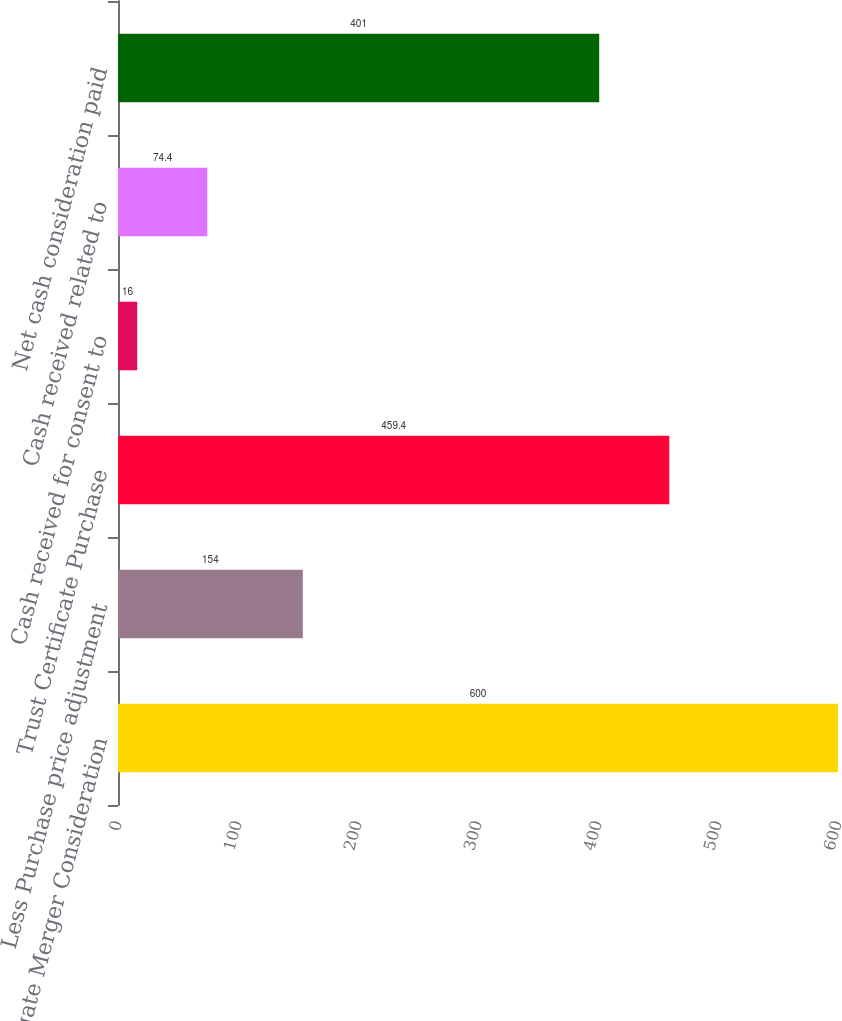<chart> <loc_0><loc_0><loc_500><loc_500><bar_chart><fcel>Aggregate Merger Consideration<fcel>Less Purchase price adjustment<fcel>Trust Certificate Purchase<fcel>Cash received for consent to<fcel>Cash received related to<fcel>Net cash consideration paid<nl><fcel>600<fcel>154<fcel>459.4<fcel>16<fcel>74.4<fcel>401<nl></chart> 